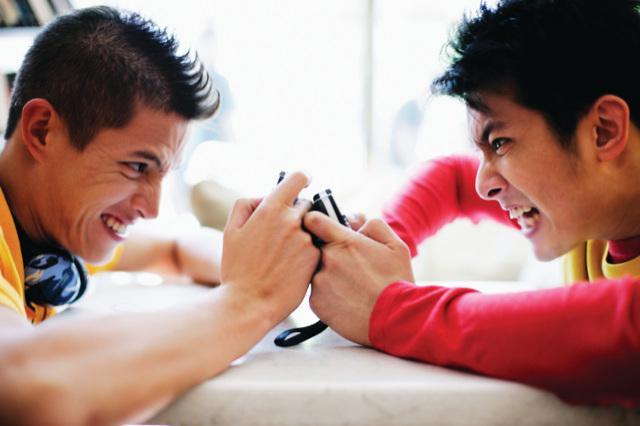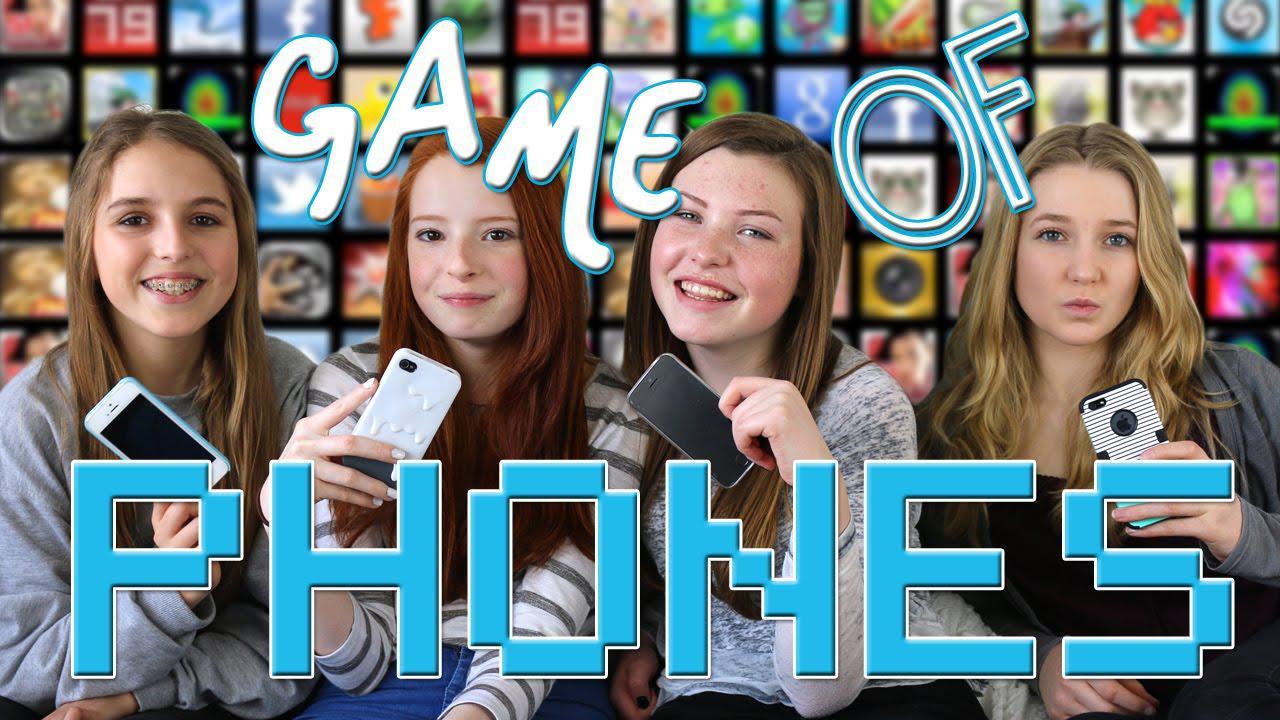The first image is the image on the left, the second image is the image on the right. For the images shown, is this caption "There are at most five people in the image pair." true? Answer yes or no. No. The first image is the image on the left, the second image is the image on the right. For the images shown, is this caption "The right image contains no more than three humans holding cell phones." true? Answer yes or no. No. 